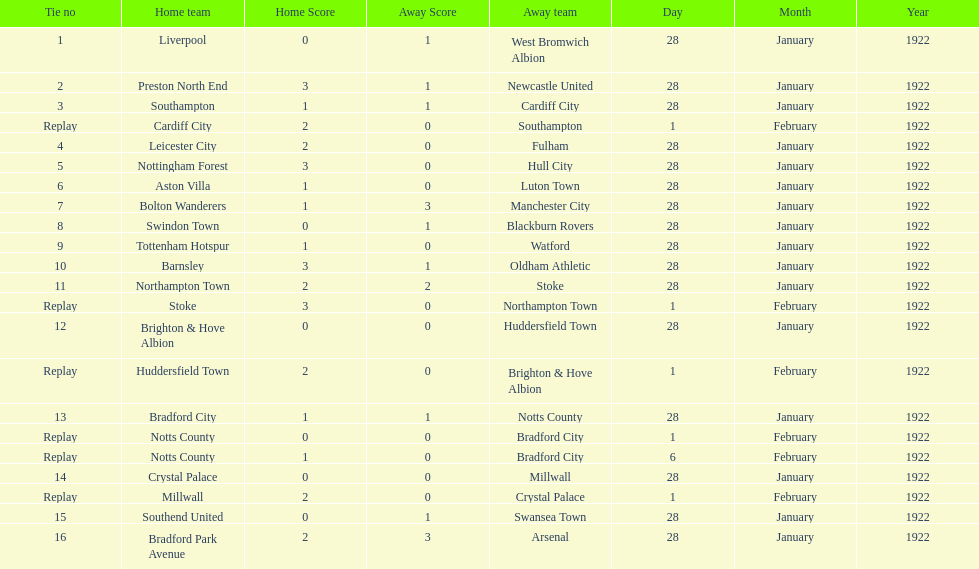What date did they play before feb 1? 28 January 1922. 